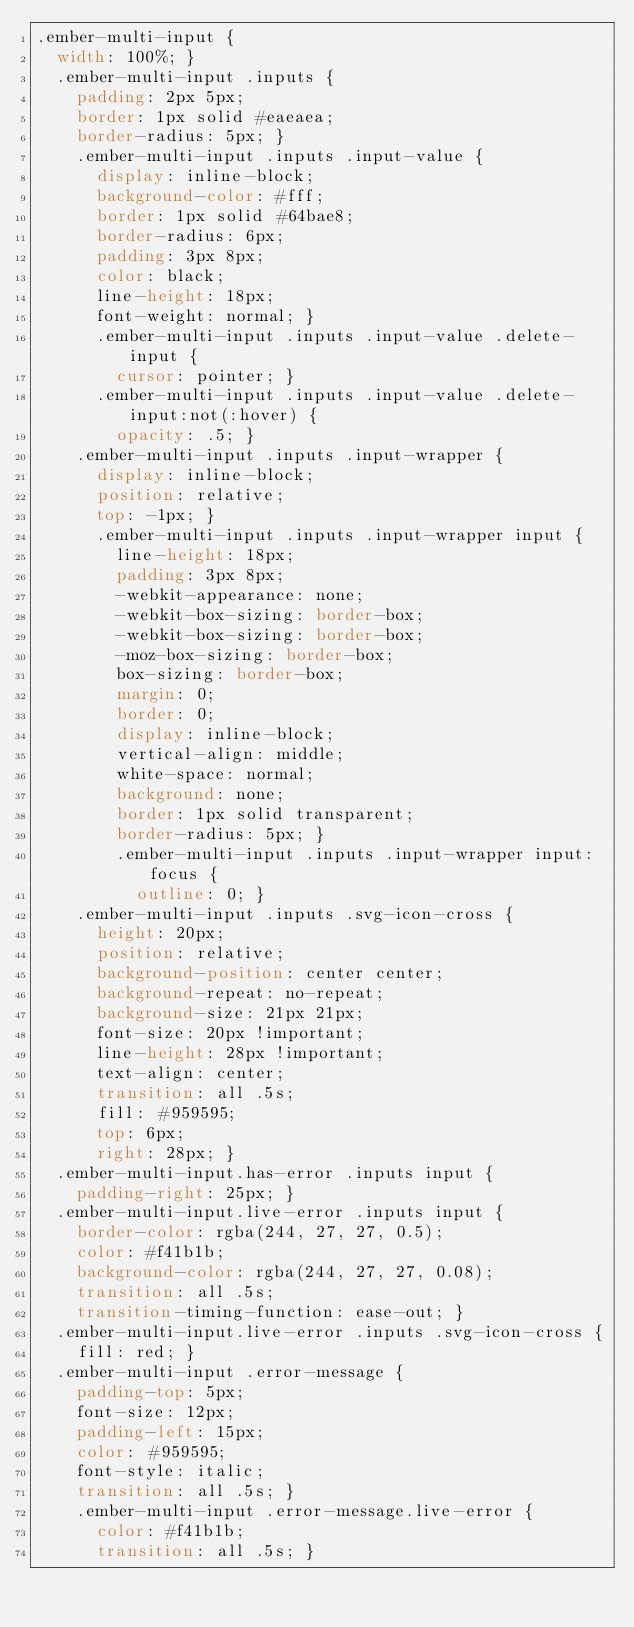Convert code to text. <code><loc_0><loc_0><loc_500><loc_500><_CSS_>.ember-multi-input {
  width: 100%; }
  .ember-multi-input .inputs {
    padding: 2px 5px;
    border: 1px solid #eaeaea;
    border-radius: 5px; }
    .ember-multi-input .inputs .input-value {
      display: inline-block;
      background-color: #fff;
      border: 1px solid #64bae8;
      border-radius: 6px;
      padding: 3px 8px;
      color: black;
      line-height: 18px;
      font-weight: normal; }
      .ember-multi-input .inputs .input-value .delete-input {
        cursor: pointer; }
      .ember-multi-input .inputs .input-value .delete-input:not(:hover) {
        opacity: .5; }
    .ember-multi-input .inputs .input-wrapper {
      display: inline-block;
      position: relative;
      top: -1px; }
      .ember-multi-input .inputs .input-wrapper input {
        line-height: 18px;
        padding: 3px 8px;
        -webkit-appearance: none;
        -webkit-box-sizing: border-box;
        -webkit-box-sizing: border-box;
        -moz-box-sizing: border-box;
        box-sizing: border-box;
        margin: 0;
        border: 0;
        display: inline-block;
        vertical-align: middle;
        white-space: normal;
        background: none;
        border: 1px solid transparent;
        border-radius: 5px; }
        .ember-multi-input .inputs .input-wrapper input:focus {
          outline: 0; }
    .ember-multi-input .inputs .svg-icon-cross {
      height: 20px;
      position: relative;
      background-position: center center;
      background-repeat: no-repeat;
      background-size: 21px 21px;
      font-size: 20px !important;
      line-height: 28px !important;
      text-align: center;
      transition: all .5s;
      fill: #959595;
      top: 6px;
      right: 28px; }
  .ember-multi-input.has-error .inputs input {
    padding-right: 25px; }
  .ember-multi-input.live-error .inputs input {
    border-color: rgba(244, 27, 27, 0.5);
    color: #f41b1b;
    background-color: rgba(244, 27, 27, 0.08);
    transition: all .5s;
    transition-timing-function: ease-out; }
  .ember-multi-input.live-error .inputs .svg-icon-cross {
    fill: red; }
  .ember-multi-input .error-message {
    padding-top: 5px;
    font-size: 12px;
    padding-left: 15px;
    color: #959595;
    font-style: italic;
    transition: all .5s; }
    .ember-multi-input .error-message.live-error {
      color: #f41b1b;
      transition: all .5s; }
</code> 